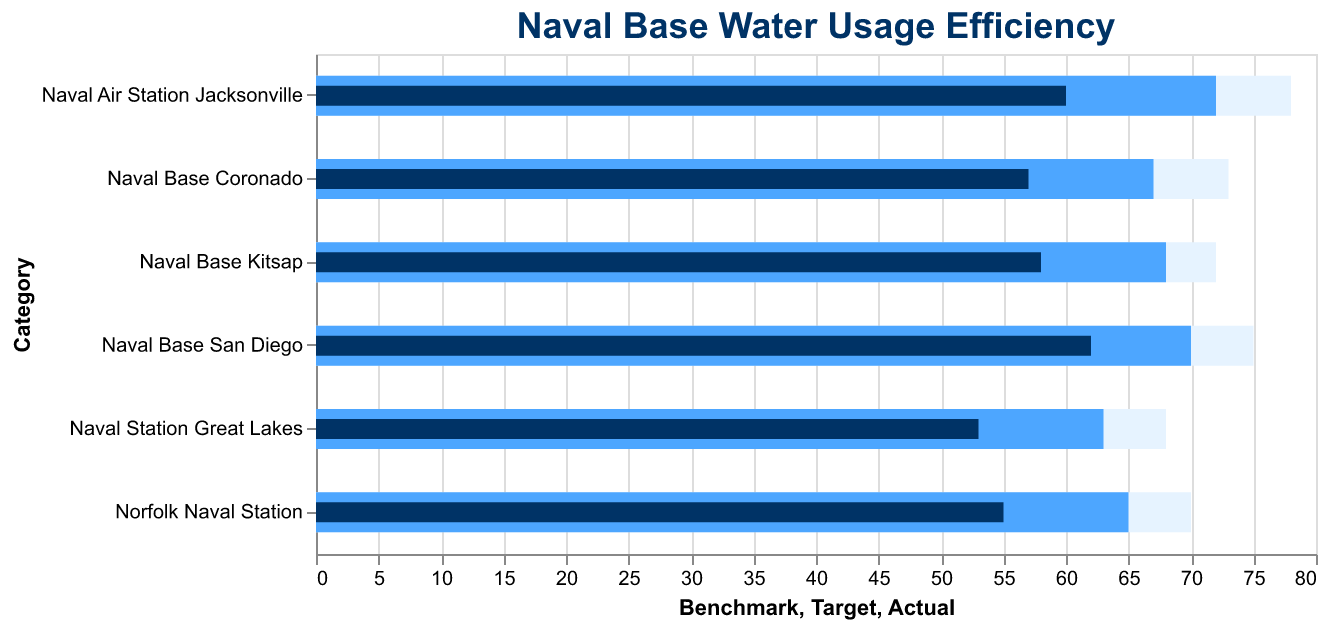How many naval bases are shown in the figure? Count the number of bars (categories) displayed in the figure. There are six naval bases listed.
Answer: 6 What is the title of the figure? The title appears at the top of the chart.
Answer: Naval Base Water Usage Efficiency Which naval base has the highest actual water usage efficiency? Look for the base with the longest dark blue bar (Actual). Naval Base San Diego has the highest actual efficiency with 62.
Answer: Naval Base San Diego How much more efficient is Norfolk Naval Station compared to Naval Station Great Lakes in terms of actual consumption? Subtract the actual value of Naval Station Great Lakes from Norfolk Naval Station. 55 - 53 = 2
Answer: 2 Which naval base has the smallest gap between actual and target usage? Calculate the differences between actual and target values for each base. The difference for Naval Base San Diego is smallest (70 - 62 = 8).
Answer: Naval Base San Diego What's the average target water usage efficiency across all naval bases? Sum all target values and divide by the number of bases: (65 + 70 + 68 + 72 + 63 + 67) / 6. The sum is 405. So, 405 / 6 = 67.5
Answer: 67.5 In which naval base is the actual water usage furthest below the benchmark? Subtract actual values from benchmark values for each base, then find the maximum difference. For Nava Air Station Jacksonville, the difference is largest (78 - 60 = 18).
Answer: Naval Air Station Jacksonville Is there any base where the actual usage meets or surpasses the target? Compare actual and target values for all bases. None of the actual values meet or surpass their target values.
Answer: No Which naval base shows the most efficient water usage when compared to its benchmark? Calculate the percentage (Actual/Benchmark) for each base and find the highest. (55/70, 62/75, 58/72, 60/78, 53/68, 57/73). Norfolk Naval Station shows highest efficiency: 55/70 ≈ 78.57%.
Answer: Norfolk Naval Station How does Naval Base Kitsap's actual water usage compare to its benchmark? Look at the actual bar (58) and benchmark bar (72) for Naval Base Kitsap. The actual water usage is 58 and the benchmark is 72. 72 - 58 = 14 units below the benchmark.
Answer: 14 units below 